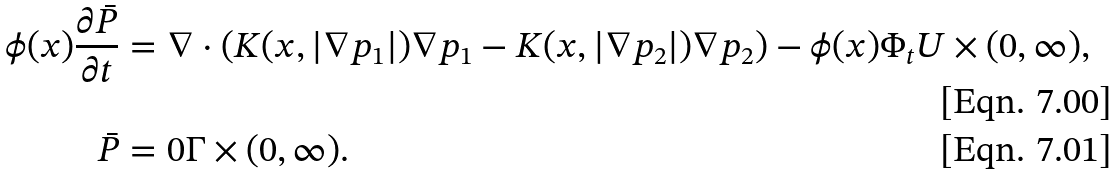Convert formula to latex. <formula><loc_0><loc_0><loc_500><loc_500>\phi ( x ) \frac { \partial \bar { P } } { \partial { t } } & = \nabla \cdot ( K ( x , | \nabla p _ { 1 } | ) \nabla p _ { 1 } - K ( x , | \nabla p _ { 2 } | ) \nabla p _ { 2 } ) - \phi ( x ) \Phi _ { t } U \times ( 0 , \infty ) , \\ \bar { P } & = 0 \Gamma \times ( 0 , \infty ) .</formula> 